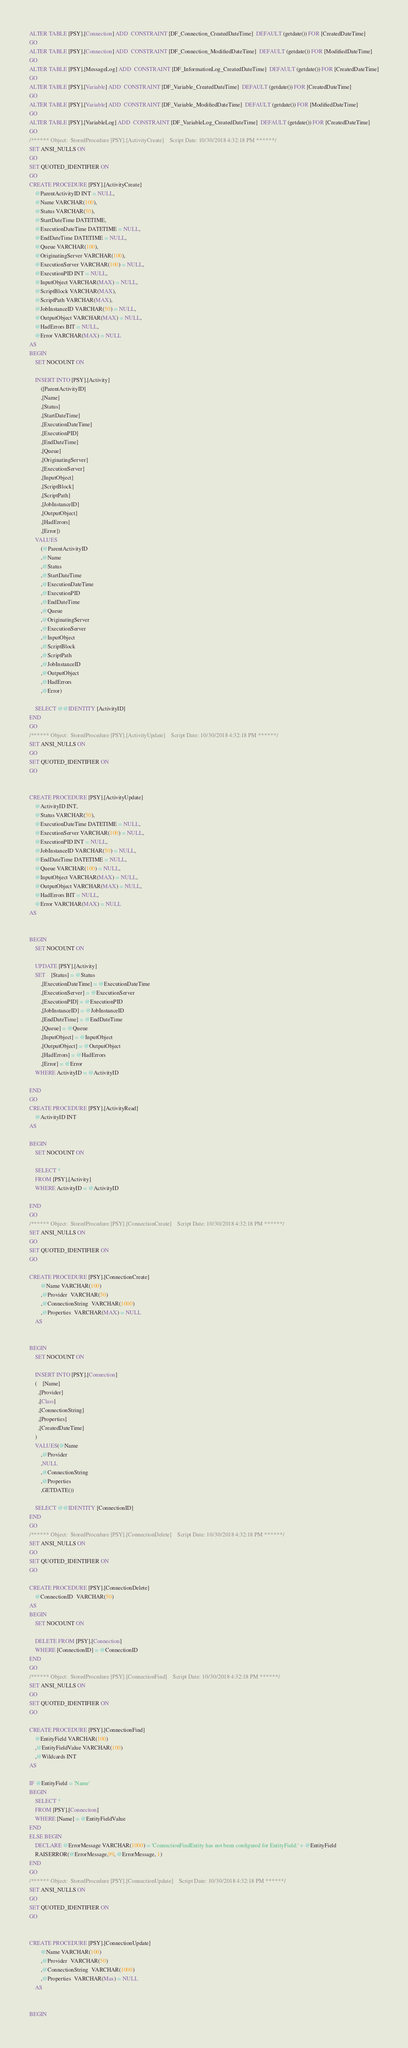Convert code to text. <code><loc_0><loc_0><loc_500><loc_500><_SQL_>ALTER TABLE [PSY].[Connection] ADD  CONSTRAINT [DF_Connection_CreatedDateTime]  DEFAULT (getdate()) FOR [CreatedDateTime]
GO
ALTER TABLE [PSY].[Connection] ADD  CONSTRAINT [DF_Connection_ModifiedDateTime]  DEFAULT (getdate()) FOR [ModifiedDateTime]
GO
ALTER TABLE [PSY].[MessageLog] ADD  CONSTRAINT [DF_InformationLog_CreatedDateTime]  DEFAULT (getdate()) FOR [CreatedDateTime]
GO
ALTER TABLE [PSY].[Variable] ADD  CONSTRAINT [DF_Variable_CreatedDateTime]  DEFAULT (getdate()) FOR [CreatedDateTime]
GO
ALTER TABLE [PSY].[Variable] ADD  CONSTRAINT [DF_Variable_ModifiedDateTime]  DEFAULT (getdate()) FOR [ModifiedDateTime]
GO
ALTER TABLE [PSY].[VariableLog] ADD  CONSTRAINT [DF_VariableLog_CreatedDateTime]  DEFAULT (getdate()) FOR [CreatedDateTime]
GO
/****** Object:  StoredProcedure [PSY].[ActivityCreate]    Script Date: 10/30/2018 4:32:18 PM ******/
SET ANSI_NULLS ON
GO
SET QUOTED_IDENTIFIER ON
GO
CREATE PROCEDURE [PSY].[ActivityCreate]
	@ParentActivityID INT = NULL,
	@Name VARCHAR(100),
	@Status VARCHAR(50),
	@StartDateTime DATETIME,
	@ExecutionDateTime DATETIME = NULL,
	@EndDateTime DATETIME = NULL,
	@Queue VARCHAR(100),
	@OriginatingServer VARCHAR(100),
	@ExecutionServer VARCHAR(100) = NULL,
	@ExecutionPID INT = NULL,
	@InputObject VARCHAR(MAX) = NULL,
	@ScriptBlock VARCHAR(MAX),
	@ScriptPath VARCHAR(MAX),
	@JobInstanceID VARCHAR(50) = NULL,
	@OutputObject VARCHAR(MAX) = NULL,
	@HadErrors BIT = NULL,
	@Error VARCHAR(MAX) = NULL
AS
BEGIN
	SET NOCOUNT ON

	INSERT INTO [PSY].[Activity]
		([ParentActivityID]
		,[Name]
		,[Status]
		,[StartDateTime]
		,[ExecutionDateTime]
		,[ExecutionPID]
		,[EndDateTime]
		,[Queue]
		,[OriginatingServer]
		,[ExecutionServer]
		,[InputObject]
		,[ScriptBlock]
		,[ScriptPath]
		,[JobInstanceID]
		,[OutputObject]
		,[HadErrors]
		,[Error])
	VALUES
		(@ParentActivityID
		,@Name
		,@Status
		,@StartDateTime
		,@ExecutionDateTime
		,@ExecutionPID
		,@EndDateTime
		,@Queue
		,@OriginatingServer
		,@ExecutionServer
		,@InputObject
		,@ScriptBlock
		,@ScriptPath
		,@JobInstanceID
		,@OutputObject
		,@HadErrors
		,@Error)

	SELECT @@IDENTITY [ActivityID]
END
GO
/****** Object:  StoredProcedure [PSY].[ActivityUpdate]    Script Date: 10/30/2018 4:32:18 PM ******/
SET ANSI_NULLS ON
GO
SET QUOTED_IDENTIFIER ON
GO


CREATE PROCEDURE [PSY].[ActivityUpdate]
	@ActivityID INT,
	@Status VARCHAR(50),
	@ExecutionDateTime DATETIME = NULL,
	@ExecutionServer VARCHAR(100) = NULL,
	@ExecutionPID INT = NULL,
	@JobInstanceID VARCHAR(50) = NULL,
	@EndDateTime DATETIME = NULL,
	@Queue VARCHAR(100) = NULL,
	@InputObject VARCHAR(MAX) = NULL,
	@OutputObject VARCHAR(MAX) = NULL,
	@HadErrors BIT = NULL,
	@Error VARCHAR(MAX) = NULL
AS

	
BEGIN
	SET NOCOUNT ON

	UPDATE [PSY].[Activity]
	SET	[Status] = @Status
		,[ExecutionDateTime] = @ExecutionDateTime
		,[ExecutionServer] = @ExecutionServer
		,[ExecutionPID] = @ExecutionPID
		,[JobInstanceID] = @JobInstanceID
		,[EndDateTime] = @EndDateTime
		,[Queue] = @Queue
		,[InputObject] = @InputObject
		,[OutputObject] = @OutputObject
		,[HadErrors] = @HadErrors
		,[Error] = @Error
	WHERE ActivityID = @ActivityID

END
GO
CREATE PROCEDURE [PSY].[ActivityRead]
	@ActivityID INT
AS

BEGIN
	SET NOCOUNT ON

	SELECT *
	FROM [PSY].[Activity]
	WHERE ActivityID = @ActivityID

END
GO
/****** Object:  StoredProcedure [PSY].[ConnectionCreate]    Script Date: 10/30/2018 4:32:18 PM ******/
SET ANSI_NULLS ON
GO
SET QUOTED_IDENTIFIER ON
GO

CREATE PROCEDURE [PSY].[ConnectionCreate]
		@Name VARCHAR(100)
		,@Provider  VARCHAR(50)
		,@ConnectionString  VARCHAR(1000)
		,@Properties  VARCHAR(MAX) = NULL
	AS

	
BEGIN
	SET NOCOUNT ON

	INSERT INTO [PSY].[Connection]
	(	[Name]
      ,[Provider]
      ,[Class]
      ,[ConnectionString]
	  ,[Properties]
      ,[CreatedDateTime]
	)
	VALUES(@Name 
		,@Provider  
		,NULL
		,@ConnectionString  
		,@Properties
		,GETDATE())

	SELECT @@IDENTITY [ConnectionID]
END
GO
/****** Object:  StoredProcedure [PSY].[ConnectionDelete]    Script Date: 10/30/2018 4:32:18 PM ******/
SET ANSI_NULLS ON
GO
SET QUOTED_IDENTIFIER ON
GO

CREATE PROCEDURE [PSY].[ConnectionDelete]
	@ConnectionID  VARCHAR(50)
AS
BEGIN
	SET NOCOUNT ON

	DELETE FROM [PSY].[Connection]
	WHERE [ConnectionID] = @ConnectionID
END
GO
/****** Object:  StoredProcedure [PSY].[ConnectionFind]    Script Date: 10/30/2018 4:32:18 PM ******/
SET ANSI_NULLS ON
GO
SET QUOTED_IDENTIFIER ON
GO

CREATE PROCEDURE [PSY].[ConnectionFind]
	@EntityField VARCHAR(100) 
    ,@EntityFieldValue VARCHAR(100)
    ,@Wildcards INT
AS

IF @EntityField = 'Name'
BEGIN
	SELECT *
	FROM [PSY].[Connection]
	WHERE [Name] = @EntityFieldValue
END
ELSE BEGIN
	DECLARE @ErrorMessage VARCHAR(1000) = 'ConnectionFindEntity has not been configured for EntityField:' + @EntityField
	RAISERROR(@ErrorMessage,99, @ErrorMessage, 1)
END
GO
/****** Object:  StoredProcedure [PSY].[ConnectionUpdate]    Script Date: 10/30/2018 4:32:18 PM ******/
SET ANSI_NULLS ON
GO
SET QUOTED_IDENTIFIER ON
GO


CREATE PROCEDURE [PSY].[ConnectionUpdate]
		@Name VARCHAR(100)
		,@Provider  VARCHAR(50)
		,@ConnectionString  VARCHAR(1000)
		,@Properties  VARCHAR(Max) = NULL
	AS

	
BEGIN</code> 